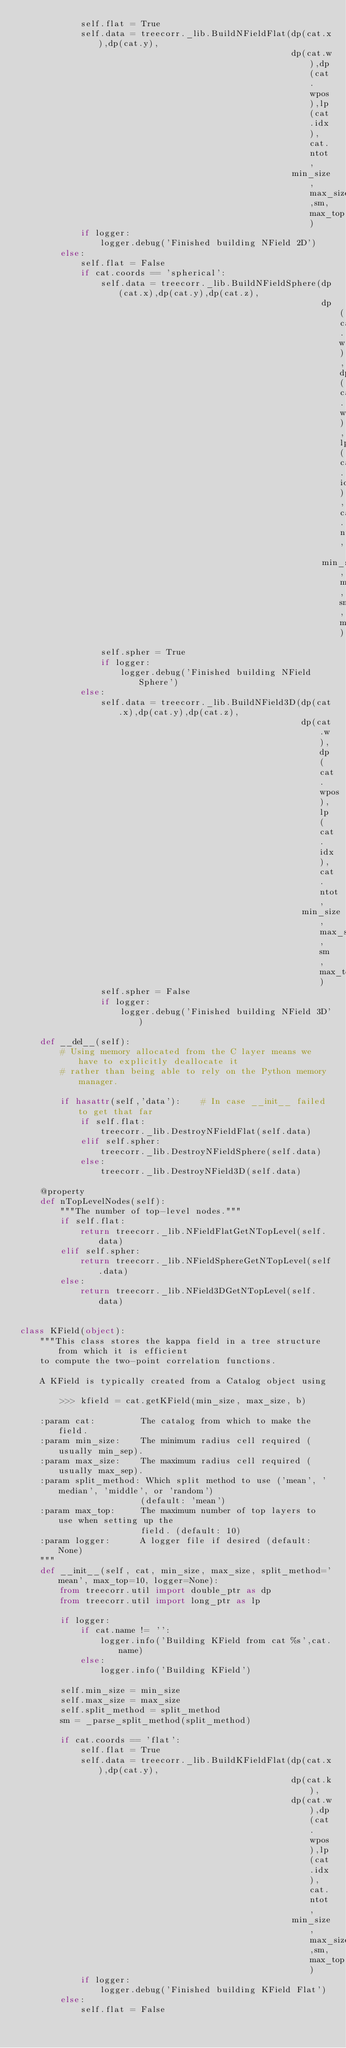<code> <loc_0><loc_0><loc_500><loc_500><_Python_>            self.flat = True
            self.data = treecorr._lib.BuildNFieldFlat(dp(cat.x),dp(cat.y),
                                                      dp(cat.w),dp(cat.wpos),lp(cat.idx),cat.ntot,
                                                      min_size,max_size,sm,max_top)
            if logger:
                logger.debug('Finished building NField 2D')
        else:
            self.flat = False
            if cat.coords == 'spherical':
                self.data = treecorr._lib.BuildNFieldSphere(dp(cat.x),dp(cat.y),dp(cat.z),
                                                            dp(cat.w),dp(cat.wpos),lp(cat.idx),cat.ntot,
                                                            min_size,max_size,sm,max_top)
                self.spher = True
                if logger:
                    logger.debug('Finished building NField Sphere')
            else:
                self.data = treecorr._lib.BuildNField3D(dp(cat.x),dp(cat.y),dp(cat.z),
                                                        dp(cat.w),dp(cat.wpos),lp(cat.idx),cat.ntot,
                                                        min_size,max_size,sm,max_top)
                self.spher = False
                if logger:
                    logger.debug('Finished building NField 3D')

    def __del__(self):
        # Using memory allocated from the C layer means we have to explicitly deallocate it
        # rather than being able to rely on the Python memory manager.

        if hasattr(self,'data'):    # In case __init__ failed to get that far
            if self.flat:
                treecorr._lib.DestroyNFieldFlat(self.data)
            elif self.spher:
                treecorr._lib.DestroyNFieldSphere(self.data)
            else:
                treecorr._lib.DestroyNField3D(self.data)

    @property
    def nTopLevelNodes(self):
        """The number of top-level nodes."""
        if self.flat:
            return treecorr._lib.NFieldFlatGetNTopLevel(self.data)
        elif self.spher:
            return treecorr._lib.NFieldSphereGetNTopLevel(self.data)
        else:
            return treecorr._lib.NField3DGetNTopLevel(self.data)


class KField(object):
    """This class stores the kappa field in a tree structure from which it is efficient
    to compute the two-point correlation functions.  

    A KField is typically created from a Catalog object using

        >>> kfield = cat.getKField(min_size, max_size, b)

    :param cat:         The catalog from which to make the field.
    :param min_size:    The minimum radius cell required (usually min_sep).
    :param max_size:    The maximum radius cell required (usually max_sep).
    :param split_method: Which split method to use ('mean', 'median', 'middle', or 'random')
                        (default: 'mean')
    :param max_top:     The maximum number of top layers to use when setting up the
                        field. (default: 10)
    :param logger:      A logger file if desired (default: None)
    """
    def __init__(self, cat, min_size, max_size, split_method='mean', max_top=10, logger=None):
        from treecorr.util import double_ptr as dp
        from treecorr.util import long_ptr as lp

        if logger:
            if cat.name != '':
                logger.info('Building KField from cat %s',cat.name)
            else:
                logger.info('Building KField')

        self.min_size = min_size
        self.max_size = max_size
        self.split_method = split_method
        sm = _parse_split_method(split_method)

        if cat.coords == 'flat':
            self.flat = True
            self.data = treecorr._lib.BuildKFieldFlat(dp(cat.x),dp(cat.y),
                                                      dp(cat.k),
                                                      dp(cat.w),dp(cat.wpos),lp(cat.idx),cat.ntot,
                                                      min_size,max_size,sm,max_top)
            if logger:
                logger.debug('Finished building KField Flat')
        else:
            self.flat = False</code> 